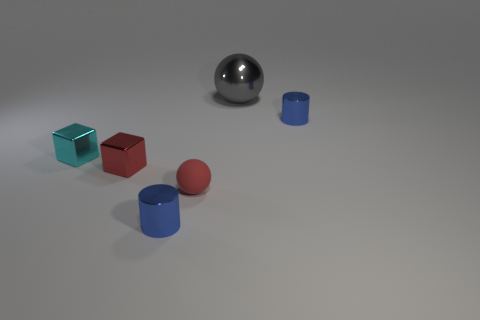What material is the ball on the left side of the gray shiny sphere?
Give a very brief answer. Rubber. Do the cyan metallic block and the rubber object have the same size?
Offer a terse response. Yes. How many other things are there of the same size as the cyan metal object?
Provide a succinct answer. 4. Do the big metal thing and the matte sphere have the same color?
Ensure brevity in your answer.  No. What is the shape of the red thing to the right of the small blue object left of the small blue cylinder that is to the right of the tiny red ball?
Ensure brevity in your answer.  Sphere. How many objects are small shiny things behind the small rubber thing or balls left of the gray thing?
Make the answer very short. 4. There is a blue metal cylinder behind the blue metal cylinder that is in front of the small red cube; what is its size?
Give a very brief answer. Small. There is a tiny metallic cylinder in front of the tiny red metallic thing; does it have the same color as the big shiny sphere?
Give a very brief answer. No. Are there any other objects of the same shape as the big shiny object?
Provide a short and direct response. Yes. What color is the shiny block that is the same size as the cyan shiny thing?
Your answer should be very brief. Red. 